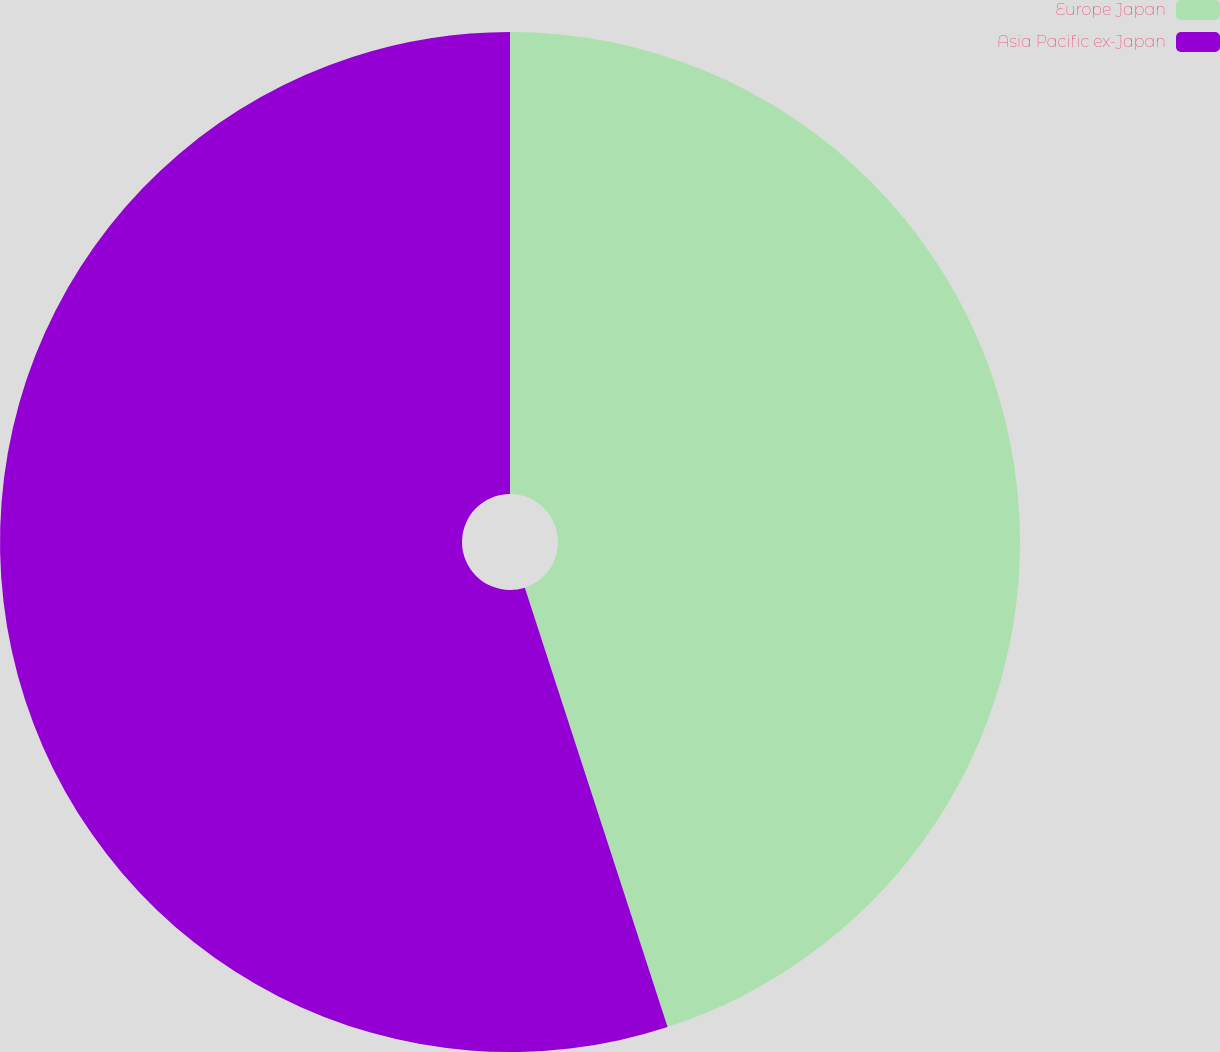Convert chart to OTSL. <chart><loc_0><loc_0><loc_500><loc_500><pie_chart><fcel>Europe Japan<fcel>Asia Pacific ex-Japan<nl><fcel>45.0%<fcel>55.0%<nl></chart> 